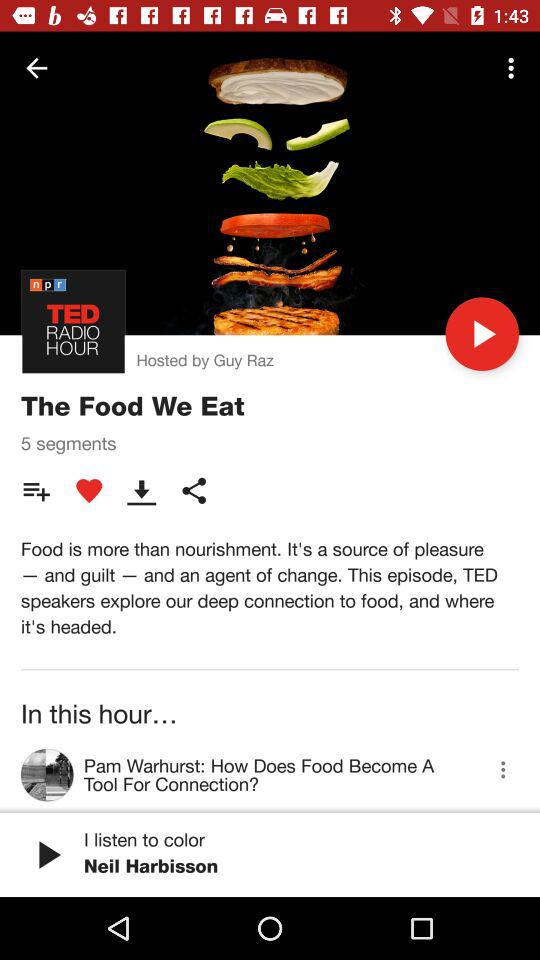How many segments are there in this episode?
Answer the question using a single word or phrase. 5 